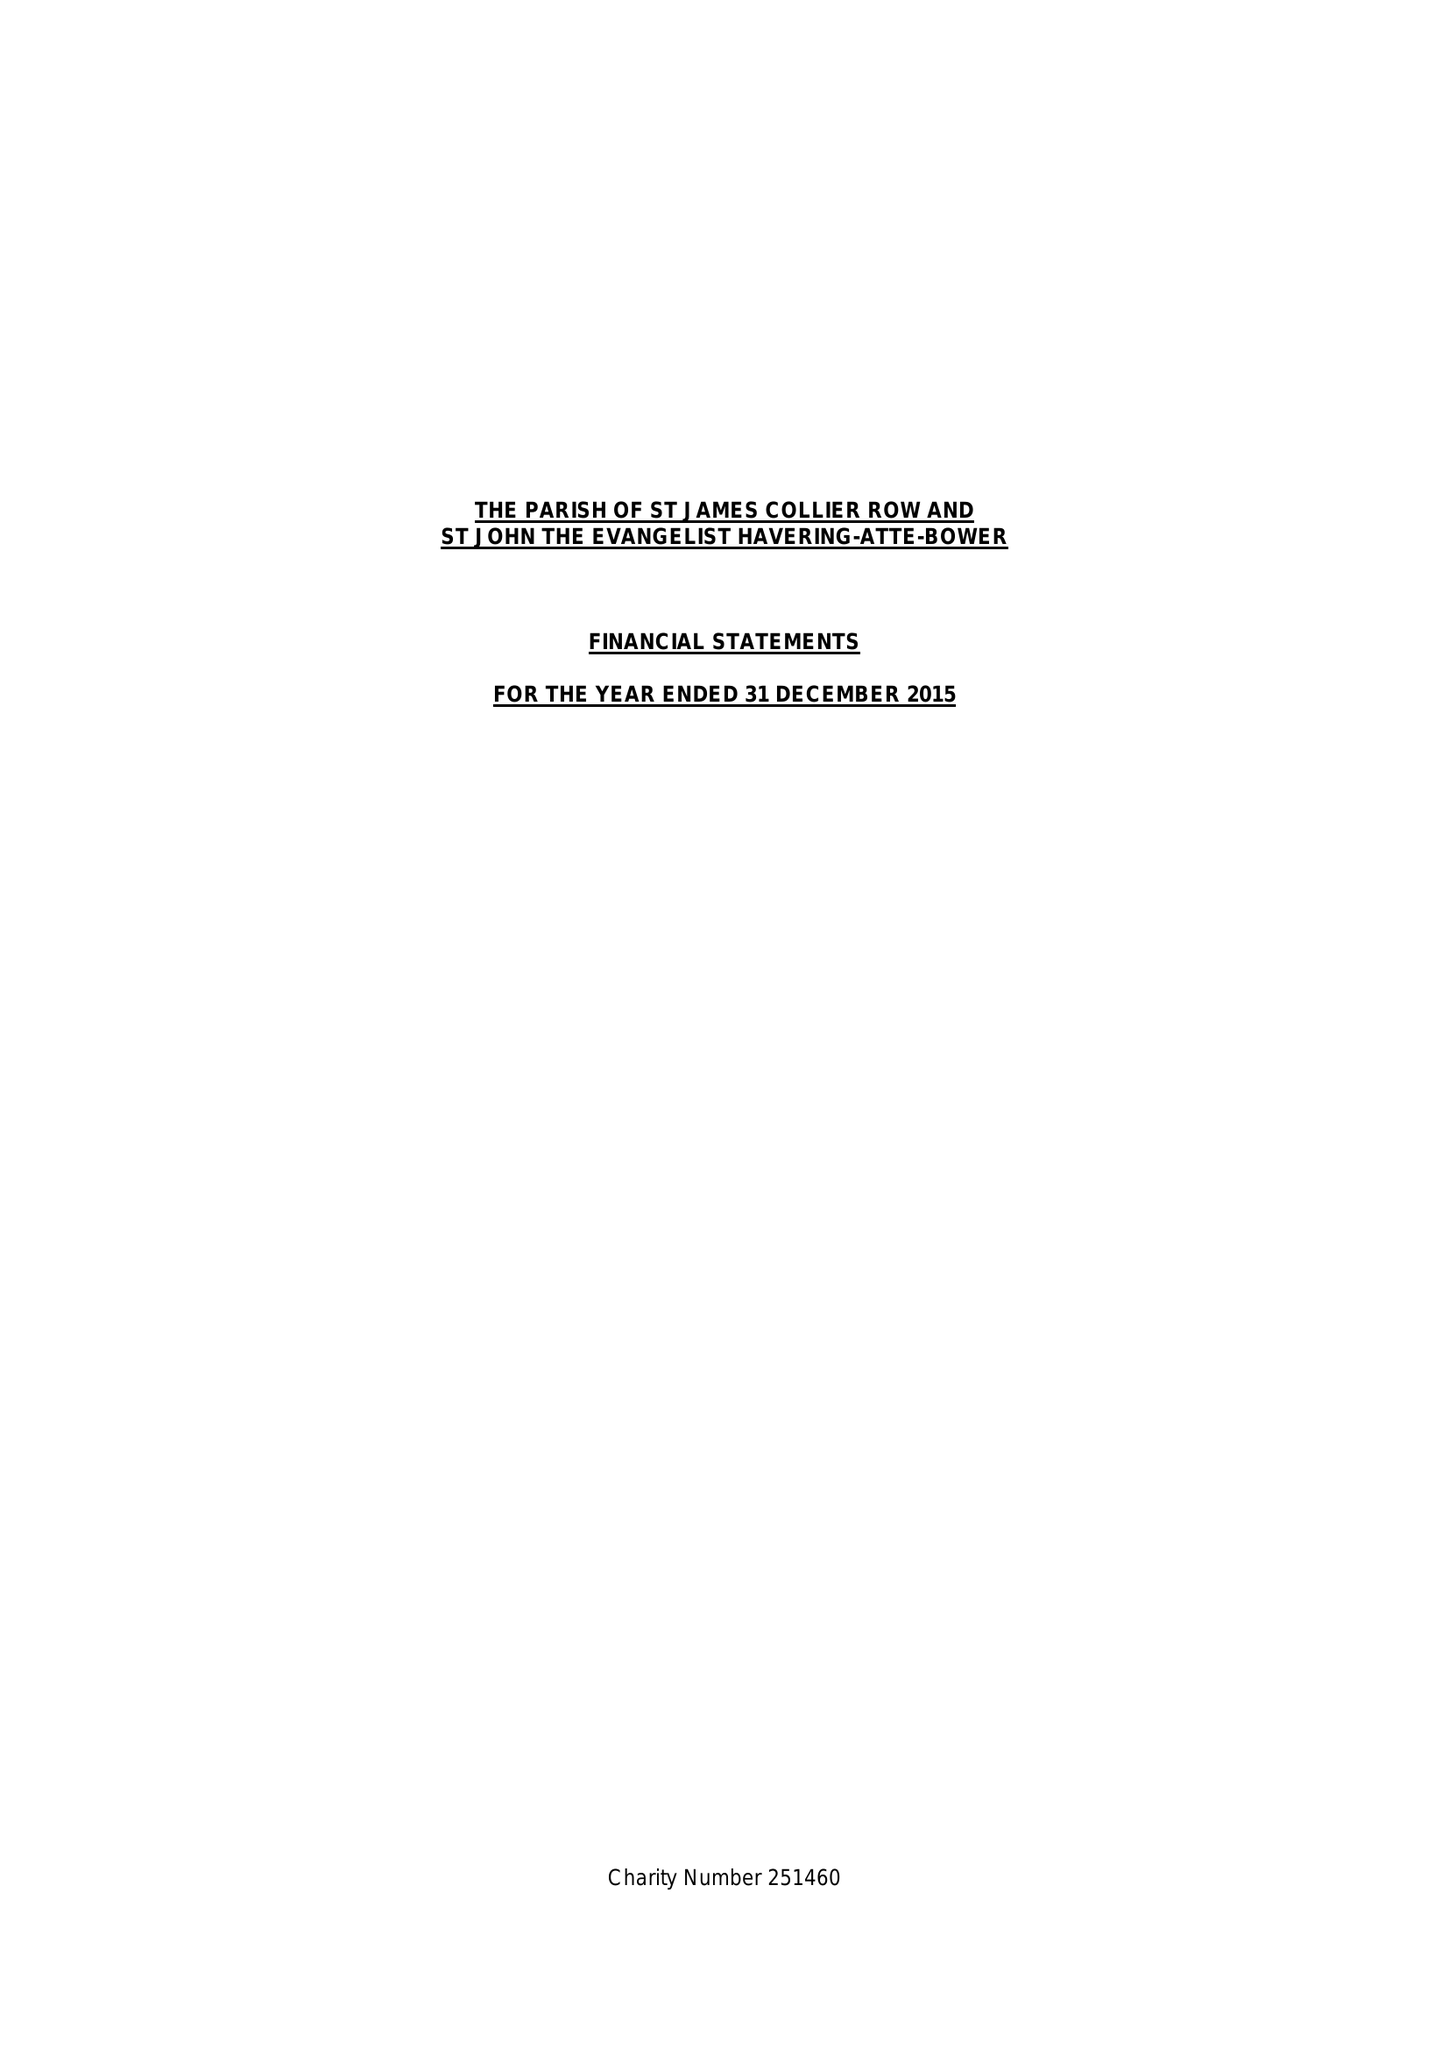What is the value for the income_annually_in_british_pounds?
Answer the question using a single word or phrase. 116262.00 